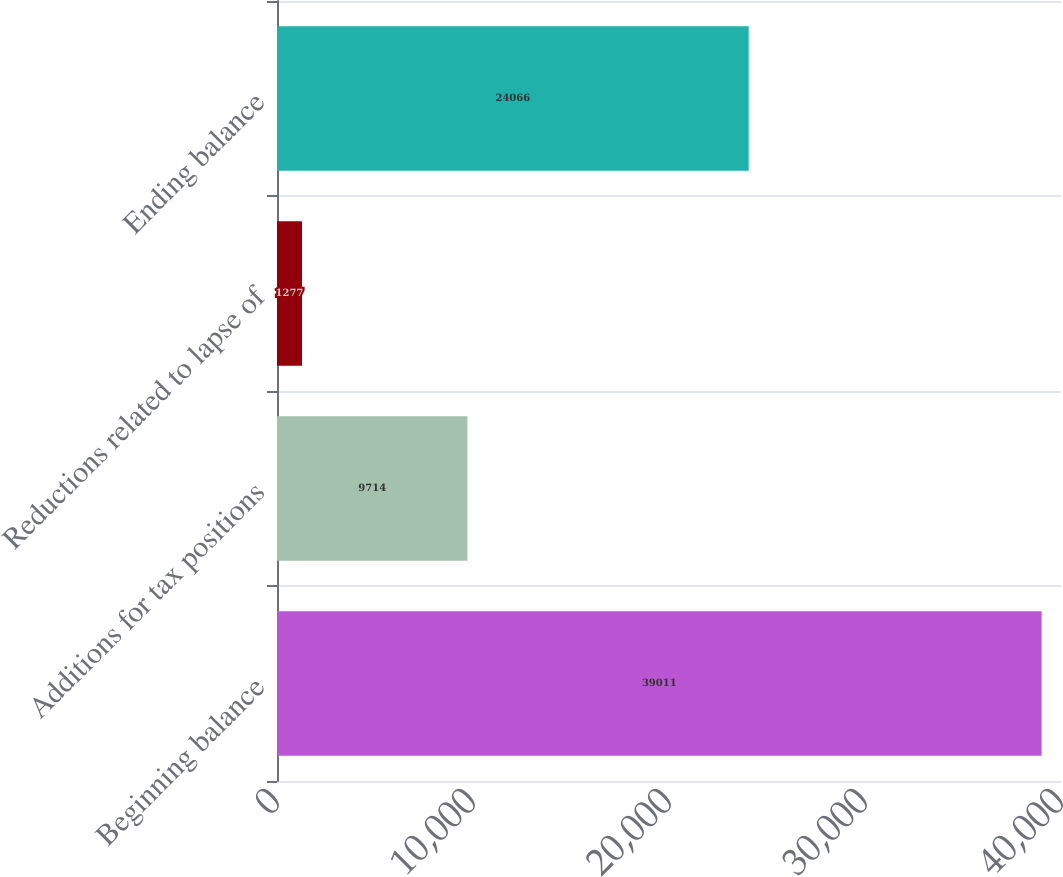Convert chart. <chart><loc_0><loc_0><loc_500><loc_500><bar_chart><fcel>Beginning balance<fcel>Additions for tax positions<fcel>Reductions related to lapse of<fcel>Ending balance<nl><fcel>39011<fcel>9714<fcel>1277<fcel>24066<nl></chart> 